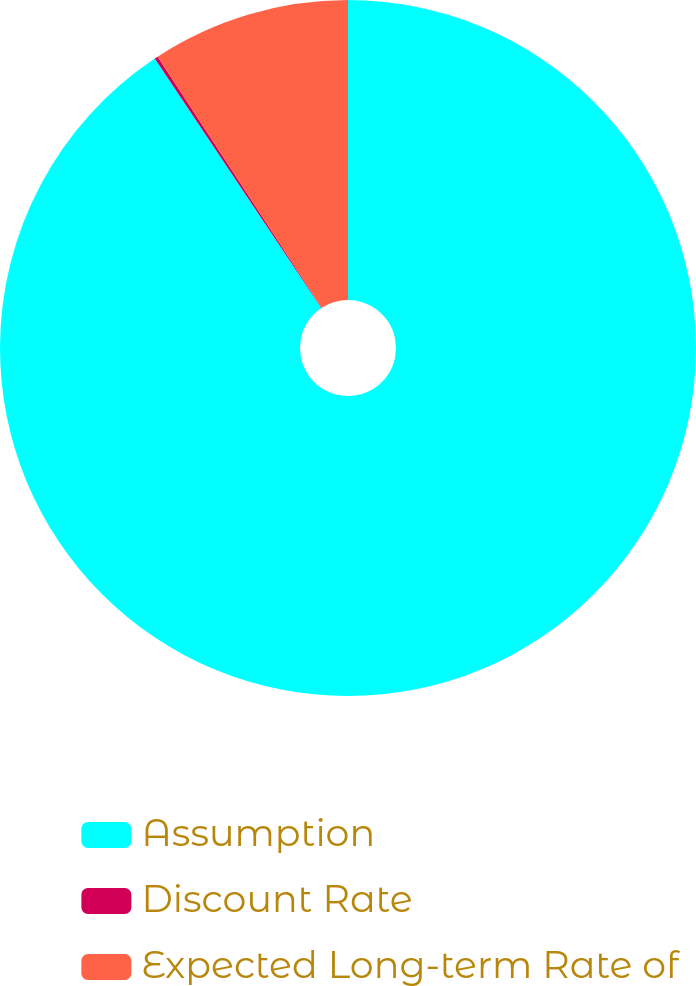Convert chart to OTSL. <chart><loc_0><loc_0><loc_500><loc_500><pie_chart><fcel>Assumption<fcel>Discount Rate<fcel>Expected Long-term Rate of<nl><fcel>90.63%<fcel>0.16%<fcel>9.21%<nl></chart> 